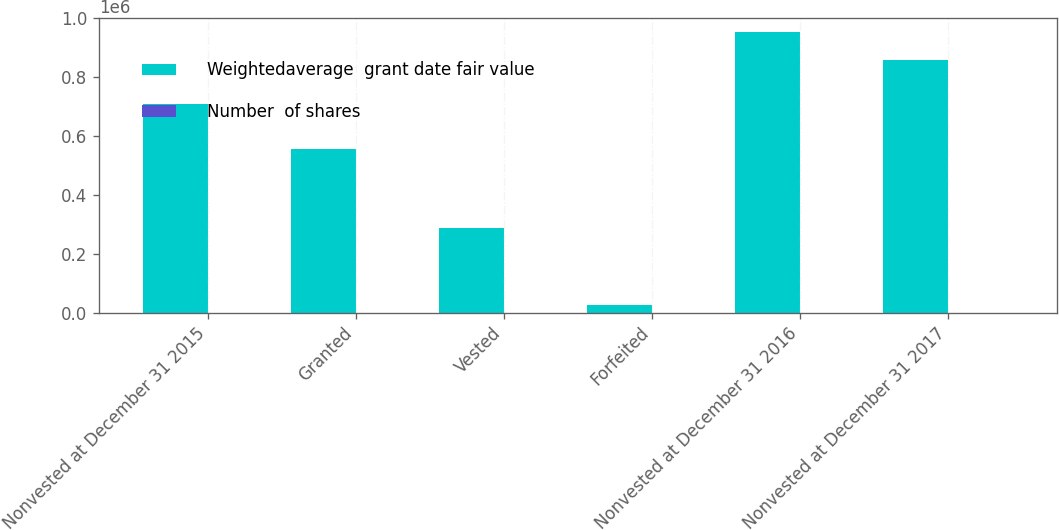<chart> <loc_0><loc_0><loc_500><loc_500><stacked_bar_chart><ecel><fcel>Nonvested at December 31 2015<fcel>Granted<fcel>Vested<fcel>Forfeited<fcel>Nonvested at December 31 2016<fcel>Nonvested at December 31 2017<nl><fcel>Weightedaverage  grant date fair value<fcel>709275<fcel>555730<fcel>287233<fcel>25100<fcel>952672<fcel>858996<nl><fcel>Number  of shares<fcel>146.64<fcel>172.67<fcel>141.27<fcel>139.56<fcel>164.62<fcel>187.01<nl></chart> 